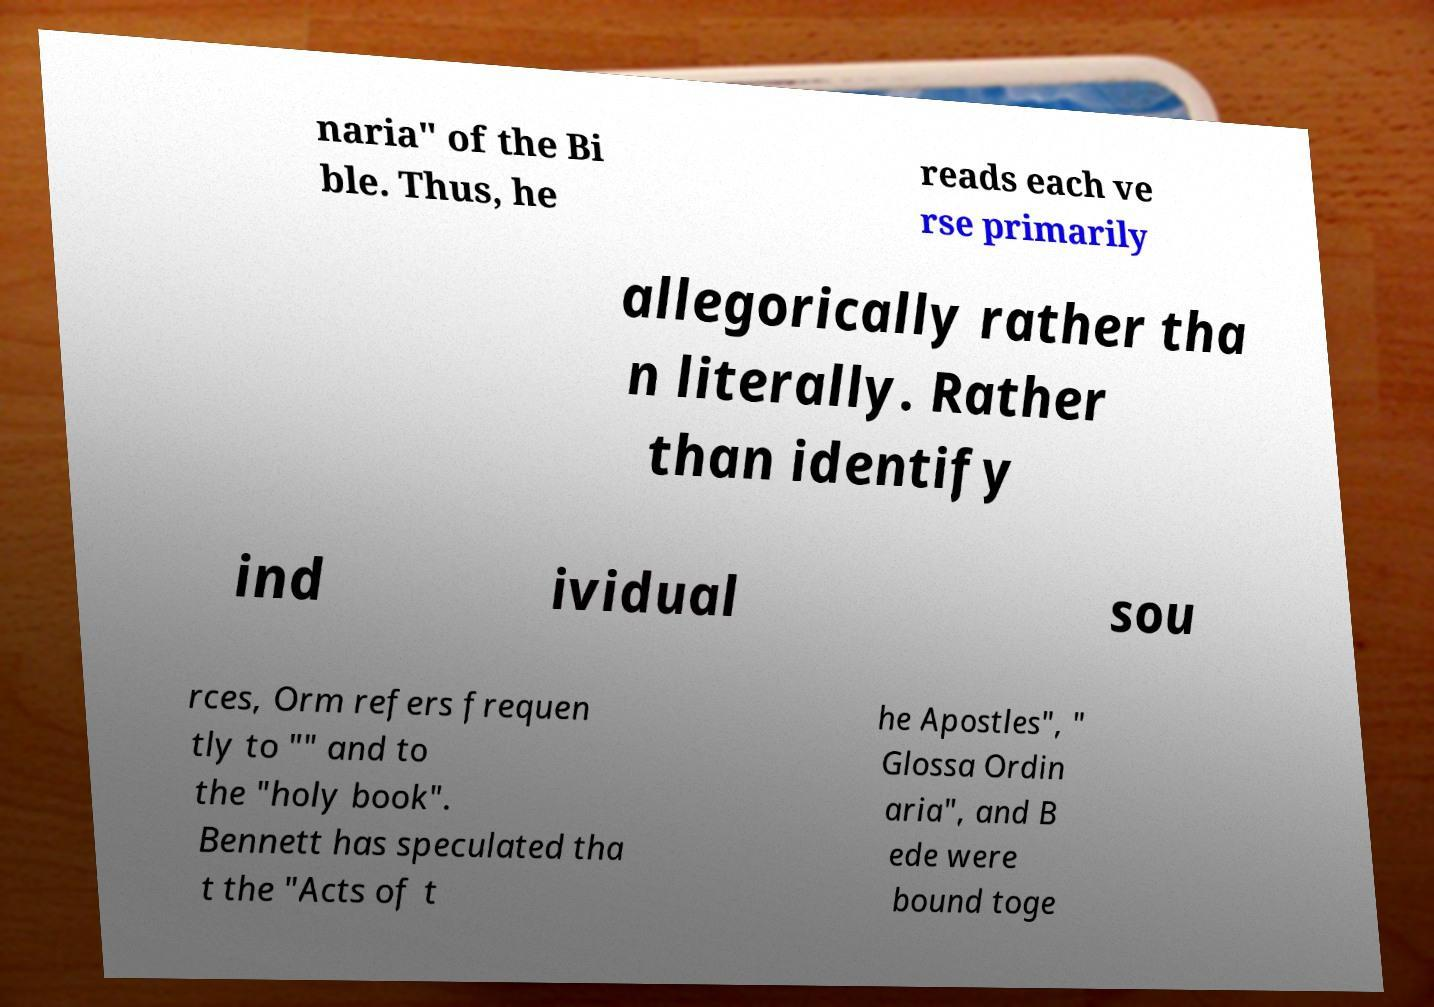What messages or text are displayed in this image? I need them in a readable, typed format. naria" of the Bi ble. Thus, he reads each ve rse primarily allegorically rather tha n literally. Rather than identify ind ividual sou rces, Orm refers frequen tly to "" and to the "holy book". Bennett has speculated tha t the "Acts of t he Apostles", " Glossa Ordin aria", and B ede were bound toge 